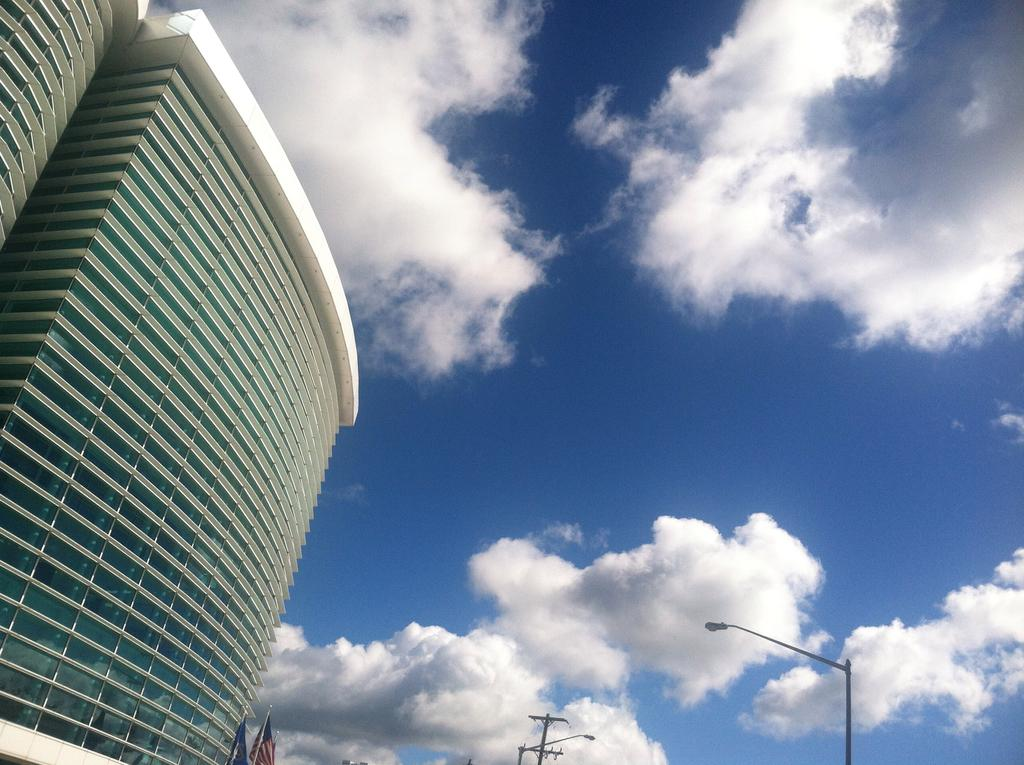What type of structures can be seen in the image? There are buildings in the image. What else can be seen in the image besides the buildings? There are street light poles in the image. What is the condition of the sky in the image? The sky is cloudy in the image. Can you tell me how many birds are in the flock in the image? There are no birds or flocks present in the image; it features buildings, street light poles, and a cloudy sky. 